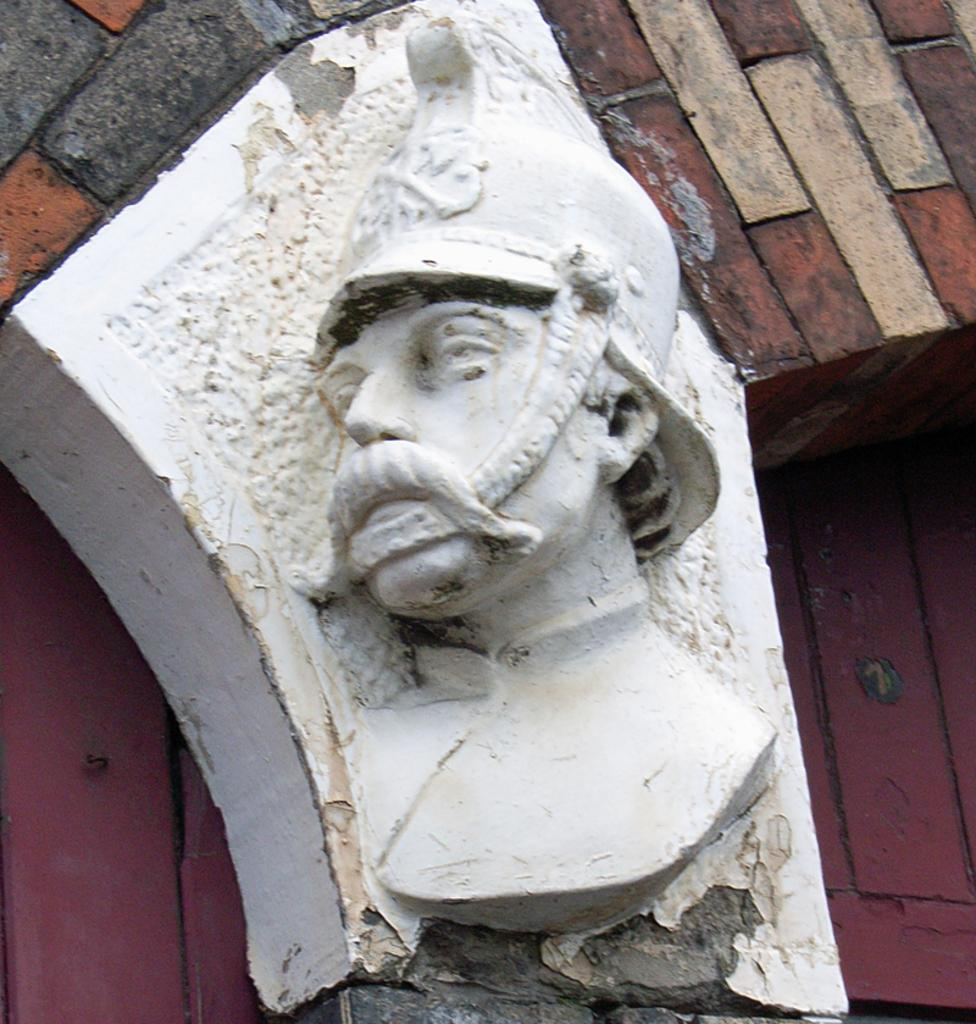What is the main subject of the image? There is a statue of a person in the image. How is the statue positioned in the image? The statue is on a pillar. What is the pillar attached to in the image? The pillar is part of a wall. What else can be seen in the image besides the statue and the pillar? There is a wall visible behind the pillar. What type of toe can be seen on the statue in the image? There is no toe visible on the statue in the image, as it is a statue and not a living person. 